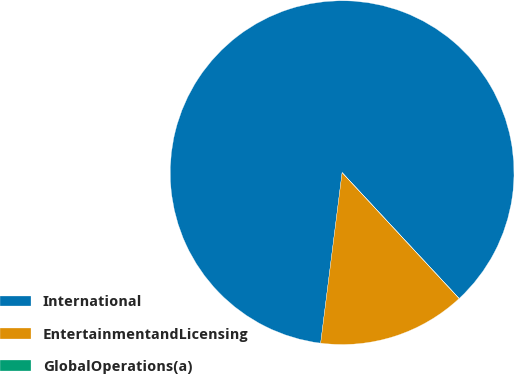<chart> <loc_0><loc_0><loc_500><loc_500><pie_chart><fcel>International<fcel>EntertainmentandLicensing<fcel>GlobalOperations(a)<nl><fcel>86.08%<fcel>13.91%<fcel>0.01%<nl></chart> 